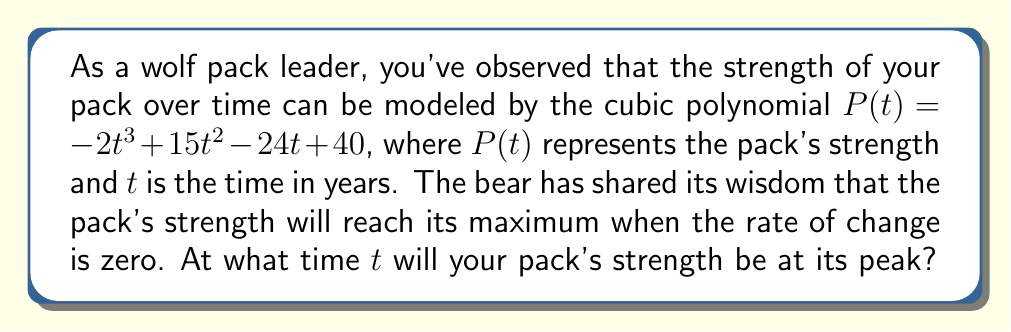Can you solve this math problem? To find the time when the pack's strength is at its maximum, we need to follow these steps:

1) The rate of change of the pack's strength is given by the first derivative of $P(t)$. Let's call this $P'(t)$.

   $P'(t) = \frac{d}{dt}(-2t^3 + 15t^2 - 24t + 40)$
   $P'(t) = -6t^2 + 30t - 24$

2) As the bear wisely suggested, the pack's strength will be at its maximum when the rate of change is zero. So, we need to solve the equation:

   $P'(t) = 0$
   $-6t^2 + 30t - 24 = 0$

3) This is a quadratic equation. We can solve it using the quadratic formula:
   $t = \frac{-b \pm \sqrt{b^2 - 4ac}}{2a}$

   Where $a = -6$, $b = 30$, and $c = -24$

4) Substituting these values:

   $t = \frac{-30 \pm \sqrt{30^2 - 4(-6)(-24)}}{2(-6)}$
   $t = \frac{-30 \pm \sqrt{900 - 576}}{-12}$
   $t = \frac{-30 \pm \sqrt{324}}{-12}$
   $t = \frac{-30 \pm 18}{-12}$

5) This gives us two solutions:
   $t = \frac{-30 + 18}{-12} = 1$ or $t = \frac{-30 - 18}{-12} = 4$

6) To determine which of these is the maximum (rather than the minimum), we can check the second derivative:

   $P''(t) = -12t + 30$

   At $t = 1$: $P''(1) = -12(1) + 30 = 18 > 0$
   At $t = 4$: $P''(4) = -12(4) + 30 = -18 < 0$

   Since the second derivative is negative at $t = 4$, this corresponds to the maximum.

Therefore, the pack's strength will be at its peak when $t = 4$ years.
Answer: The pack's strength will reach its maximum at $t = 4$ years. 